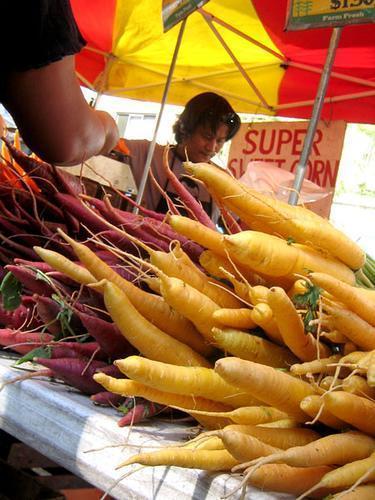How many carrots are there?
Give a very brief answer. 8. How many people can be seen?
Give a very brief answer. 2. How many characters on the digitized reader board on the top front of the bus are numerals?
Give a very brief answer. 0. 